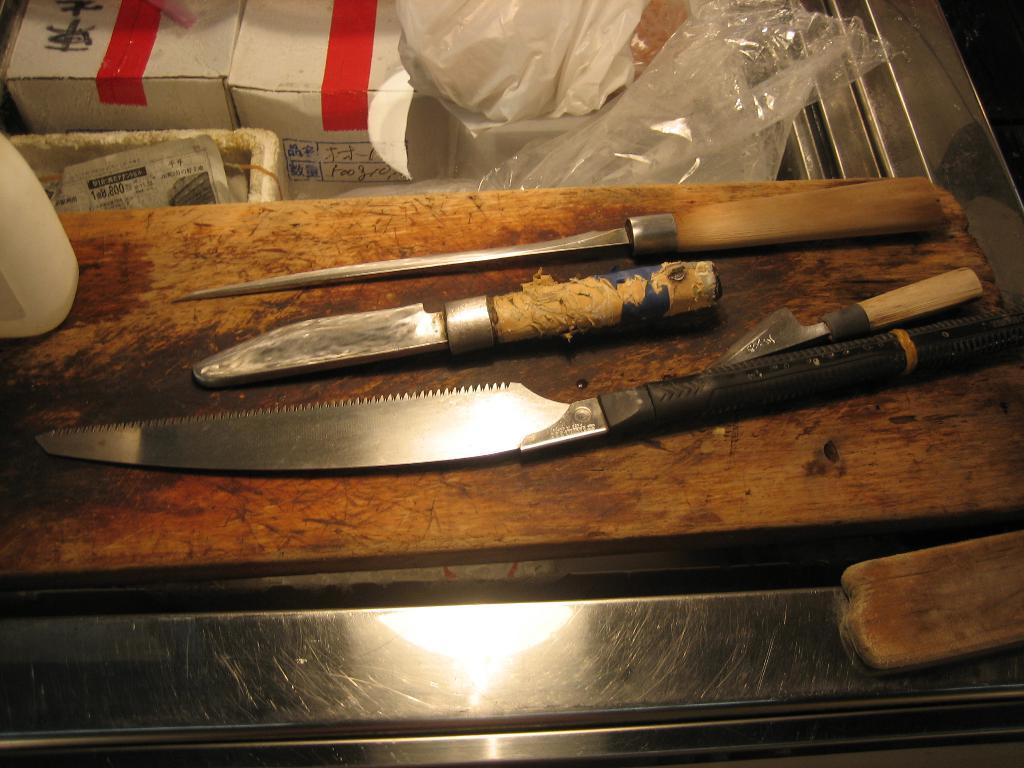Describe this image in one or two sentences. In this picture we can see few knives, plastic covers, boxes and a bottle. 